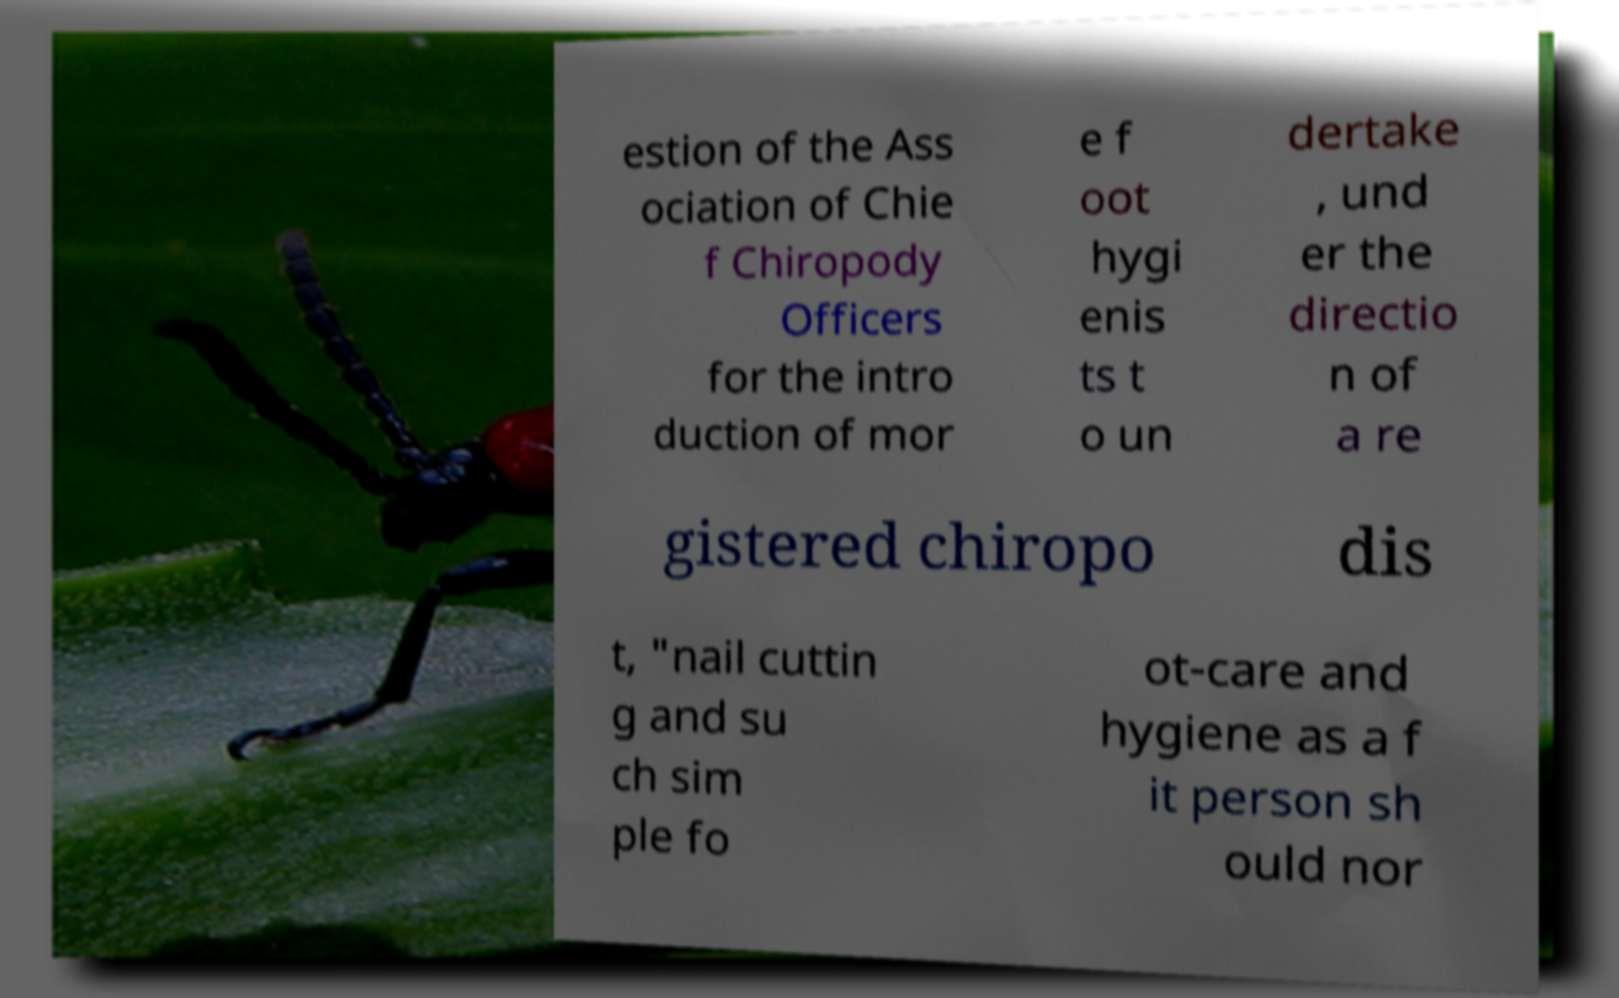Could you assist in decoding the text presented in this image and type it out clearly? estion of the Ass ociation of Chie f Chiropody Officers for the intro duction of mor e f oot hygi enis ts t o un dertake , und er the directio n of a re gistered chiropo dis t, "nail cuttin g and su ch sim ple fo ot-care and hygiene as a f it person sh ould nor 